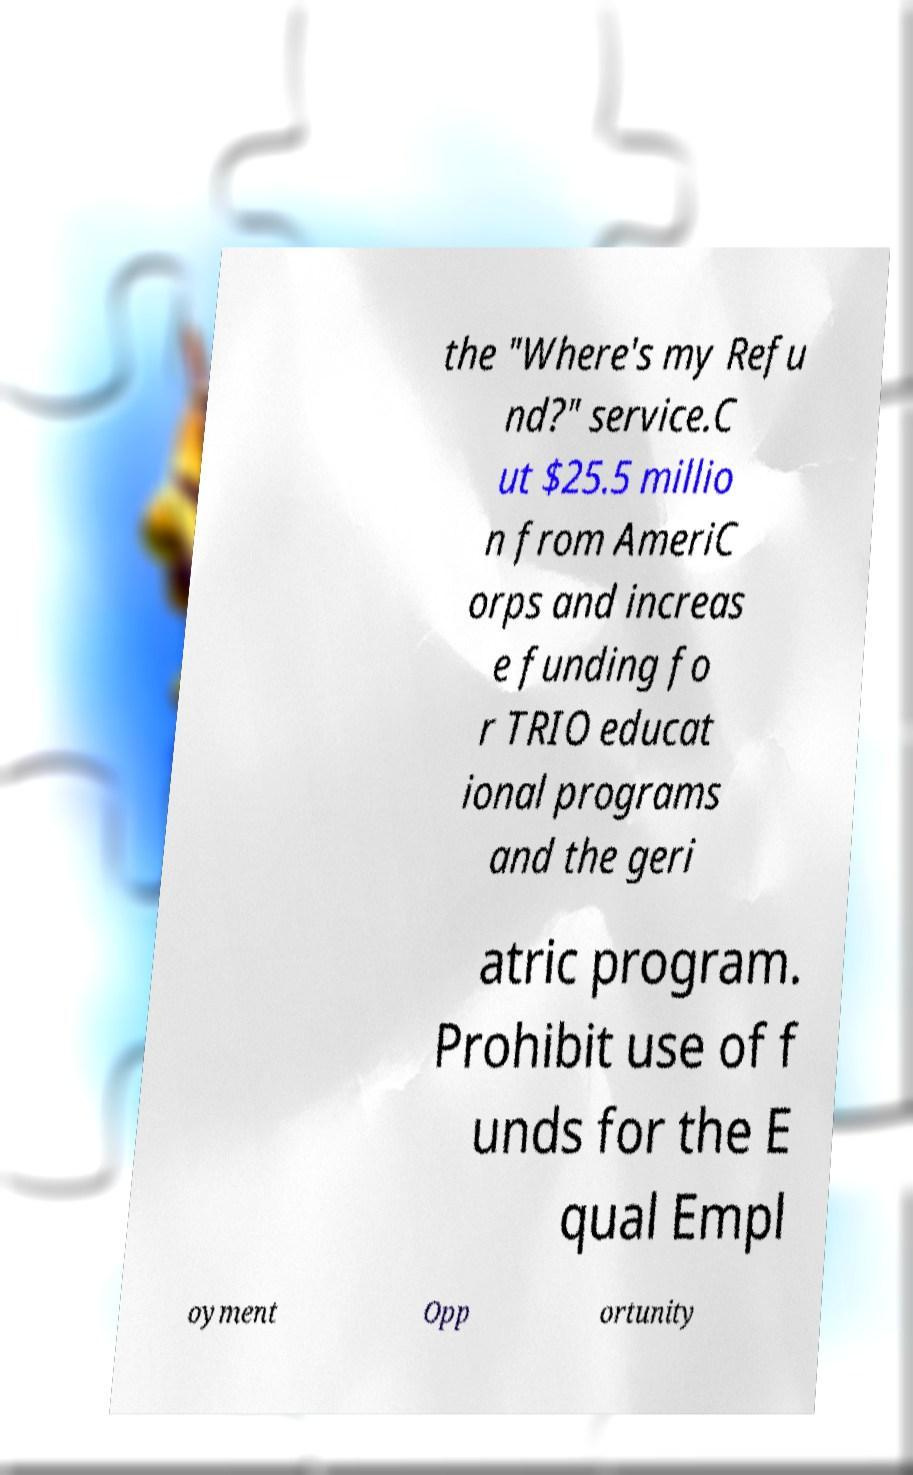I need the written content from this picture converted into text. Can you do that? the "Where's my Refu nd?" service.C ut $25.5 millio n from AmeriC orps and increas e funding fo r TRIO educat ional programs and the geri atric program. Prohibit use of f unds for the E qual Empl oyment Opp ortunity 